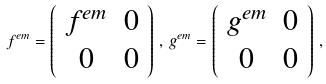Convert formula to latex. <formula><loc_0><loc_0><loc_500><loc_500>f ^ { e m } = \left ( \begin{array} { c c } { { f ^ { e m } } } & { 0 } \\ { 0 } & { 0 } \end{array} \right ) \, , \, g ^ { e m } = \left ( \begin{array} { c c } { { g ^ { e m } } } & { 0 } \\ { 0 } & { 0 } \end{array} \right ) \, ,</formula> 